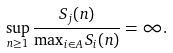Convert formula to latex. <formula><loc_0><loc_0><loc_500><loc_500>\sup _ { n \geq 1 } \frac { S _ { j } ( n ) } { \max _ { i \in A } S _ { i } ( n ) } = \infty .</formula> 